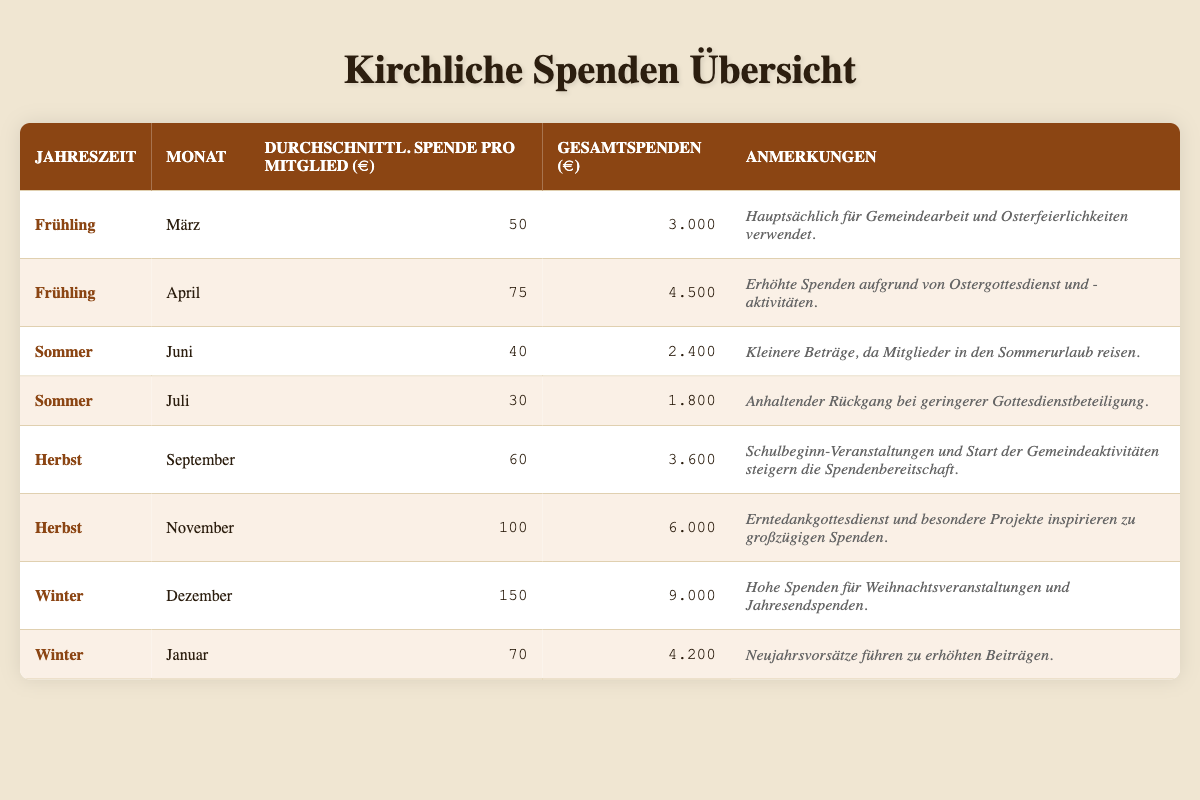What was the total donation amount in December? According to the table, the total donations for December are explicitly listed, which is 9,000 euros.
Answer: 9,000 What was the average donation per member in November? The table displays the average donation per member for November, which is recorded as 100 euros.
Answer: 100 Which month had the highest average donation per member and what was the amount? By reviewing the table, December had the highest average donation per member at 150 euros.
Answer: December, 150 What was the total donation amount for the spring season? To find the total for spring, sum the total donations for March and April: 3,000 (March) + 4,500 (April) = 7,500 euros.
Answer: 7,500 Did the average donation per member increase or decrease from June to July? From the table, the average donation per member in June was 40 euros, and in July, it decreased to 30 euros. Thus, it decreased.
Answer: Decrease Which season had the lowest average donation per member? The table shows that summer had the lowest average donation per member, specifically 30 euros in July.
Answer: Summer How much more in total donations was received in November compared to June? To determine this, subtract the total donations for June (2,400 euros) from November (6,000 euros): 6,000 - 2,400 = 3,600 euros.
Answer: 3,600 Was the total donation amount in January higher than in March? Comparing the total donations, January recorded 4,200 euros, while March was 3,000 euros. Therefore, the total for January is higher.
Answer: Yes What patterns can be observed regarding donations during the summer months? The table indicates a consistent decline in both average donations per member and total donations during the summer months (June and July). In June, the average was 40 euros, decreasing to 30 euros in July. Total donations also fell from 2,400 euros in June to 1,800 euros in July.
Answer: Decreasing trend 